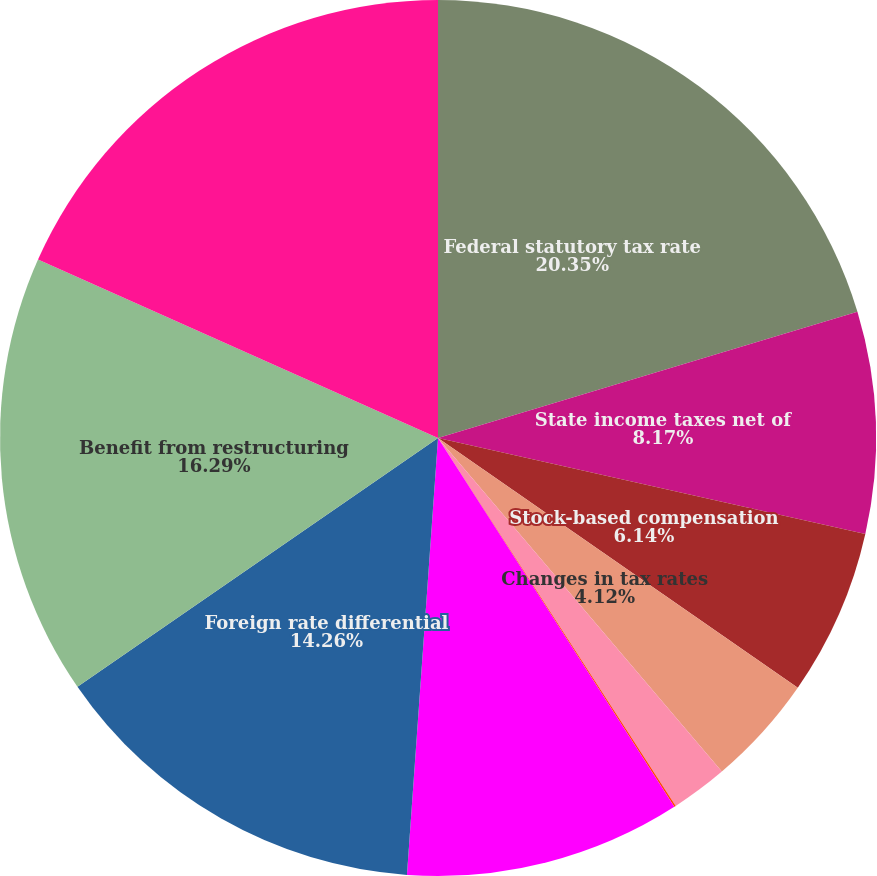<chart> <loc_0><loc_0><loc_500><loc_500><pie_chart><fcel>Federal statutory tax rate<fcel>State income taxes net of<fcel>Stock-based compensation<fcel>Changes in tax rates<fcel>Uncertain tax positions<fcel>Research and experimentation<fcel>Adjustments of prior year<fcel>Foreign rate differential<fcel>Benefit from restructuring<fcel>Domestic production activity<nl><fcel>20.35%<fcel>8.17%<fcel>6.14%<fcel>4.12%<fcel>2.09%<fcel>0.06%<fcel>10.2%<fcel>14.26%<fcel>16.29%<fcel>18.32%<nl></chart> 